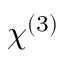Convert formula to latex. <formula><loc_0><loc_0><loc_500><loc_500>\chi ^ { ( 3 ) }</formula> 